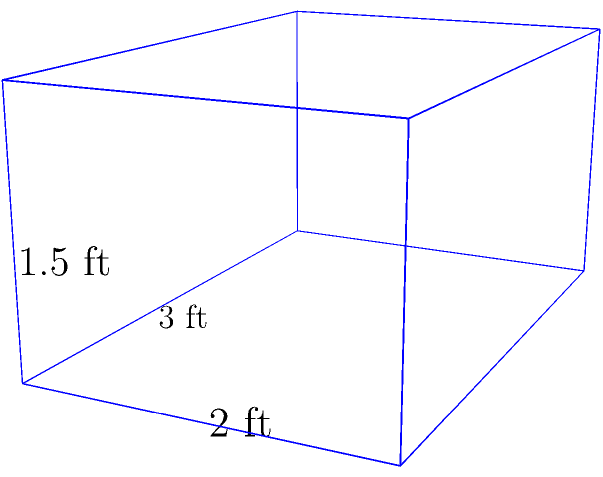You're building an eco-friendly composting bin for your organic garden waste. The bin is shaped like a rectangular prism with dimensions of 3 feet in length, 2 feet in width, and 1.5 feet in height. What is the volume of the composting bin in cubic feet? To calculate the volume of a rectangular prism, we use the formula:

$$V = l \times w \times h$$

Where:
$V$ = volume
$l$ = length
$w$ = width
$h$ = height

Given dimensions:
$l = 3$ feet
$w = 2$ feet
$h = 1.5$ feet

Substituting these values into the formula:

$$V = 3 \text{ ft} \times 2 \text{ ft} \times 1.5 \text{ ft}$$

$$V = 9 \text{ cubic feet}$$

Therefore, the volume of the composting bin is 9 cubic feet.
Answer: 9 cubic feet 